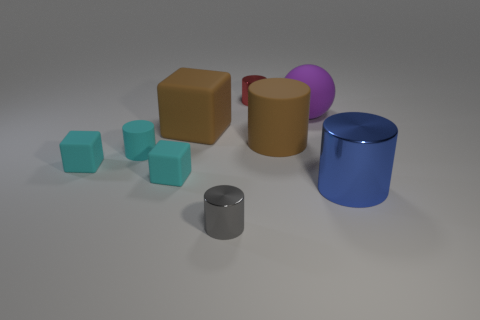Subtract all blue balls. How many cyan cubes are left? 2 Subtract 3 cylinders. How many cylinders are left? 2 Subtract all cyan cylinders. How many cylinders are left? 4 Subtract all cyan cylinders. How many cylinders are left? 4 Add 1 red shiny things. How many objects exist? 10 Subtract all brown cylinders. Subtract all gray cubes. How many cylinders are left? 4 Subtract all cylinders. How many objects are left? 4 Add 6 small cylinders. How many small cylinders exist? 9 Subtract 0 green cubes. How many objects are left? 9 Subtract all tiny brown metallic things. Subtract all gray metallic things. How many objects are left? 8 